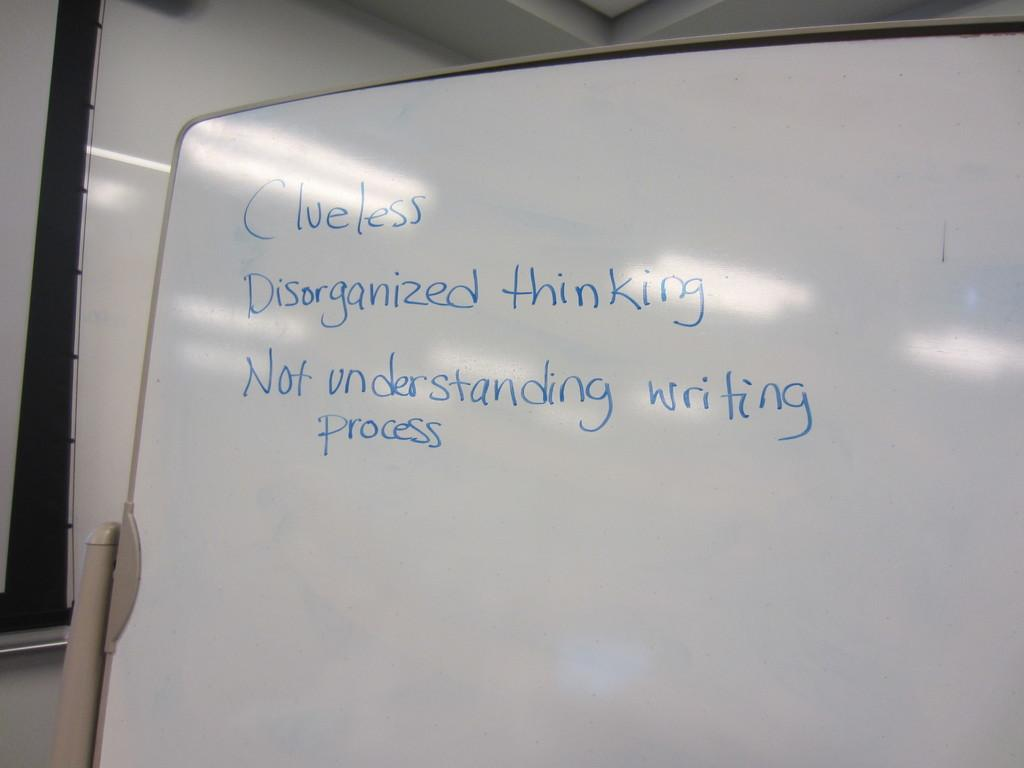<image>
Give a short and clear explanation of the subsequent image. On a mostly empty whiteboard is written Clueless, Disorganized thinking, and Not understanding writing process. 